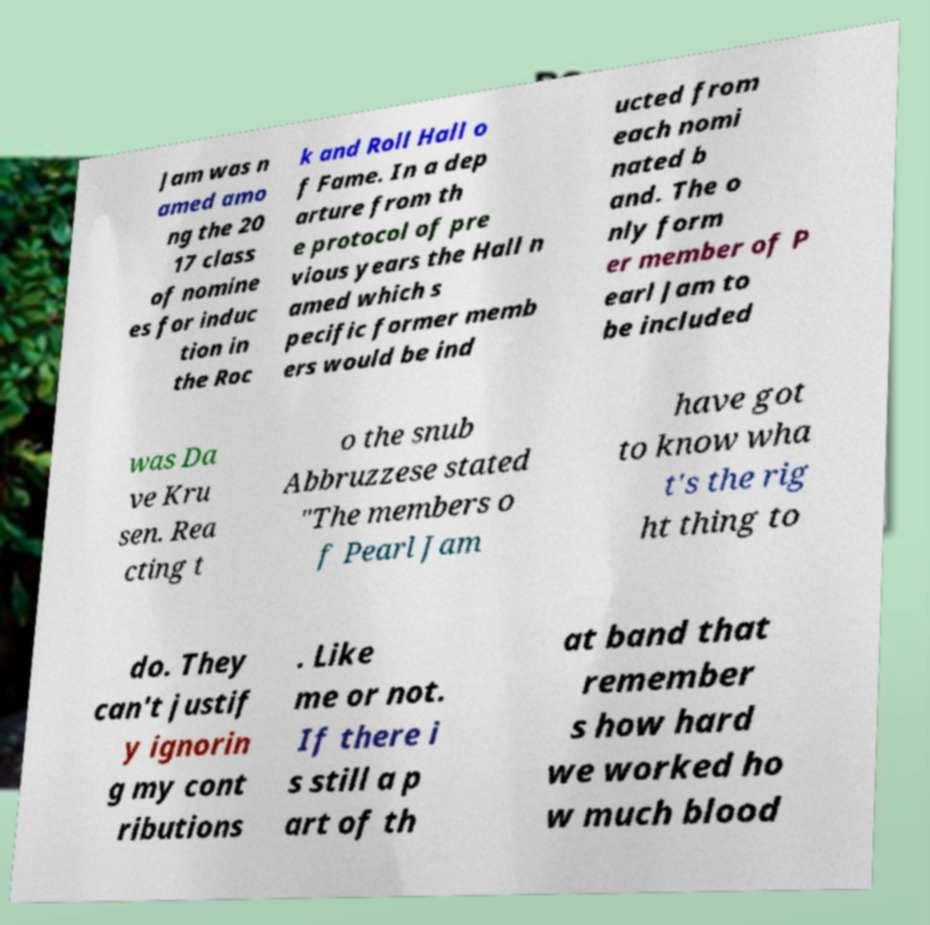For documentation purposes, I need the text within this image transcribed. Could you provide that? Jam was n amed amo ng the 20 17 class of nomine es for induc tion in the Roc k and Roll Hall o f Fame. In a dep arture from th e protocol of pre vious years the Hall n amed which s pecific former memb ers would be ind ucted from each nomi nated b and. The o nly form er member of P earl Jam to be included was Da ve Kru sen. Rea cting t o the snub Abbruzzese stated "The members o f Pearl Jam have got to know wha t's the rig ht thing to do. They can't justif y ignorin g my cont ributions . Like me or not. If there i s still a p art of th at band that remember s how hard we worked ho w much blood 